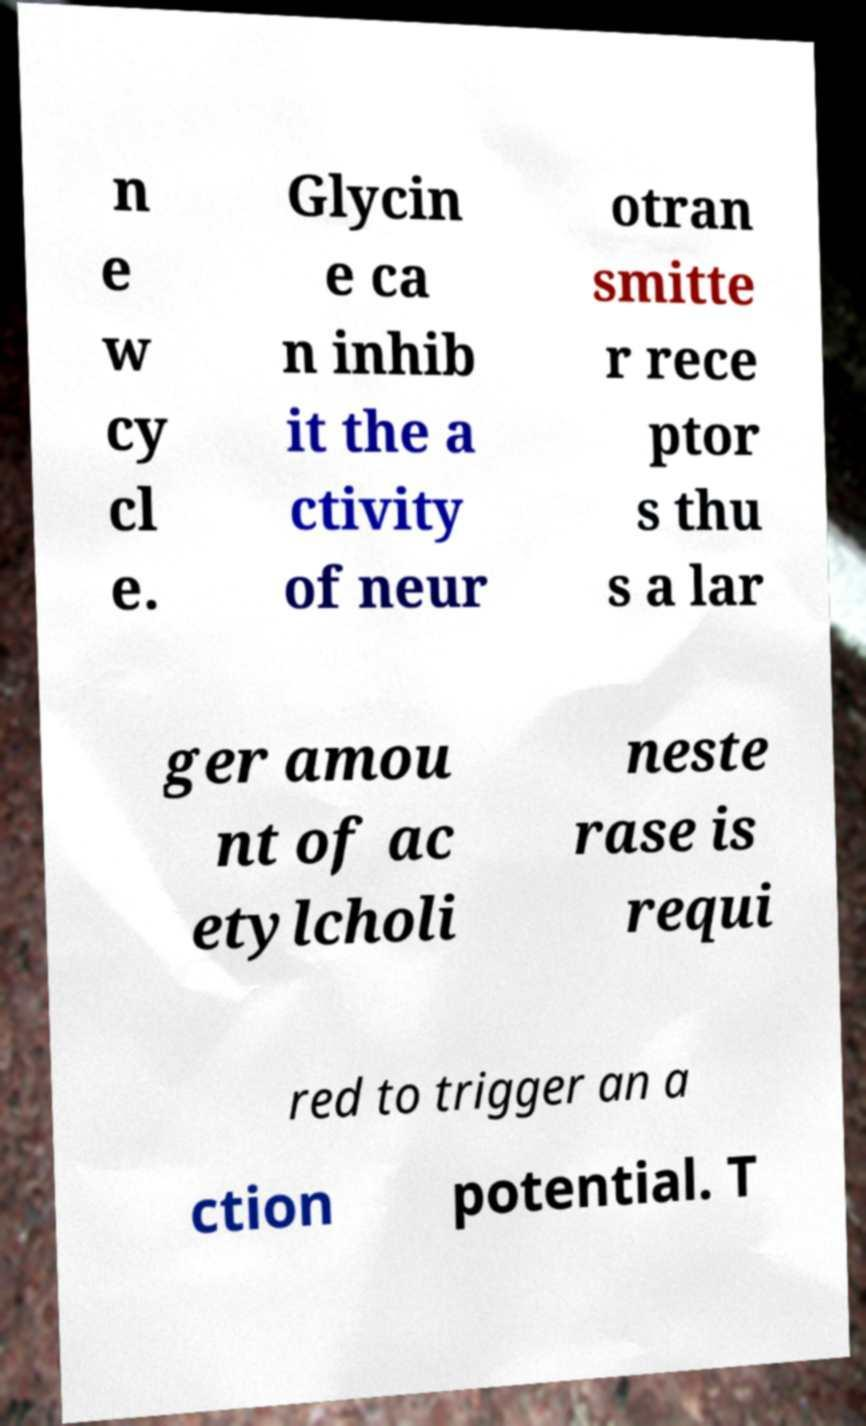Please identify and transcribe the text found in this image. n e w cy cl e. Glycin e ca n inhib it the a ctivity of neur otran smitte r rece ptor s thu s a lar ger amou nt of ac etylcholi neste rase is requi red to trigger an a ction potential. T 